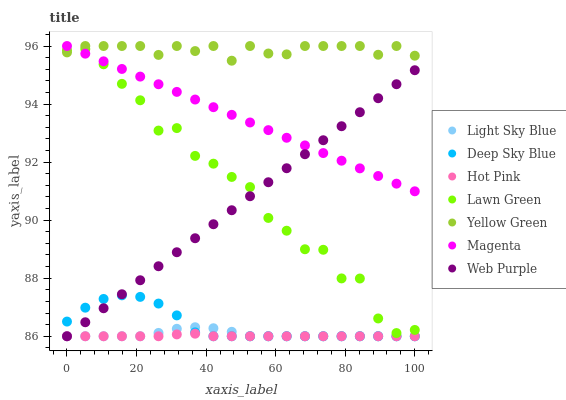Does Hot Pink have the minimum area under the curve?
Answer yes or no. Yes. Does Yellow Green have the maximum area under the curve?
Answer yes or no. Yes. Does Yellow Green have the minimum area under the curve?
Answer yes or no. No. Does Hot Pink have the maximum area under the curve?
Answer yes or no. No. Is Web Purple the smoothest?
Answer yes or no. Yes. Is Lawn Green the roughest?
Answer yes or no. Yes. Is Yellow Green the smoothest?
Answer yes or no. No. Is Yellow Green the roughest?
Answer yes or no. No. Does Hot Pink have the lowest value?
Answer yes or no. Yes. Does Yellow Green have the lowest value?
Answer yes or no. No. Does Magenta have the highest value?
Answer yes or no. Yes. Does Hot Pink have the highest value?
Answer yes or no. No. Is Light Sky Blue less than Yellow Green?
Answer yes or no. Yes. Is Yellow Green greater than Web Purple?
Answer yes or no. Yes. Does Light Sky Blue intersect Deep Sky Blue?
Answer yes or no. Yes. Is Light Sky Blue less than Deep Sky Blue?
Answer yes or no. No. Is Light Sky Blue greater than Deep Sky Blue?
Answer yes or no. No. Does Light Sky Blue intersect Yellow Green?
Answer yes or no. No. 